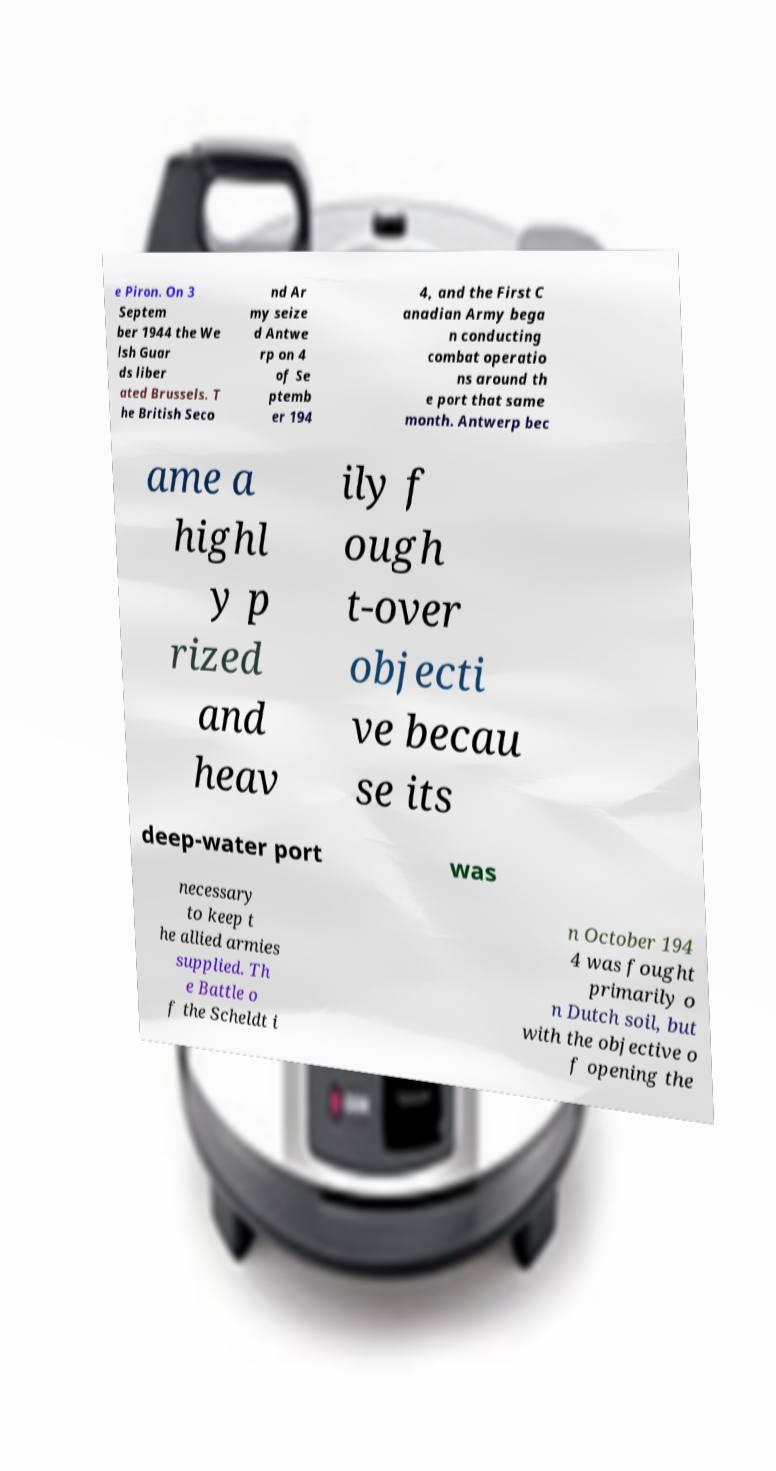I need the written content from this picture converted into text. Can you do that? e Piron. On 3 Septem ber 1944 the We lsh Guar ds liber ated Brussels. T he British Seco nd Ar my seize d Antwe rp on 4 of Se ptemb er 194 4, and the First C anadian Army bega n conducting combat operatio ns around th e port that same month. Antwerp bec ame a highl y p rized and heav ily f ough t-over objecti ve becau se its deep-water port was necessary to keep t he allied armies supplied. Th e Battle o f the Scheldt i n October 194 4 was fought primarily o n Dutch soil, but with the objective o f opening the 